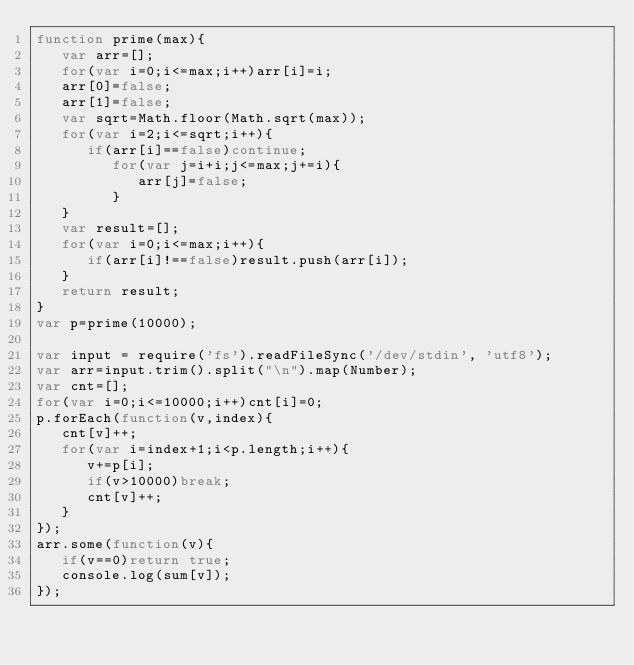Convert code to text. <code><loc_0><loc_0><loc_500><loc_500><_JavaScript_>function prime(max){
   var arr=[];
   for(var i=0;i<=max;i++)arr[i]=i;
   arr[0]=false;
   arr[1]=false;
   var sqrt=Math.floor(Math.sqrt(max));
   for(var i=2;i<=sqrt;i++){
      if(arr[i]==false)continue;
         for(var j=i+i;j<=max;j+=i){
            arr[j]=false;
         }
   }
   var result=[];
   for(var i=0;i<=max;i++){
      if(arr[i]!==false)result.push(arr[i]);
   }
   return result;
}
var p=prime(10000);

var input = require('fs').readFileSync('/dev/stdin', 'utf8');
var arr=input.trim().split("\n").map(Number);
var cnt=[];
for(var i=0;i<=10000;i++)cnt[i]=0;
p.forEach(function(v,index){
   cnt[v]++;
   for(var i=index+1;i<p.length;i++){
      v+=p[i];
      if(v>10000)break;
      cnt[v]++;
   }
});
arr.some(function(v){
   if(v==0)return true;
   console.log(sum[v]);
});</code> 